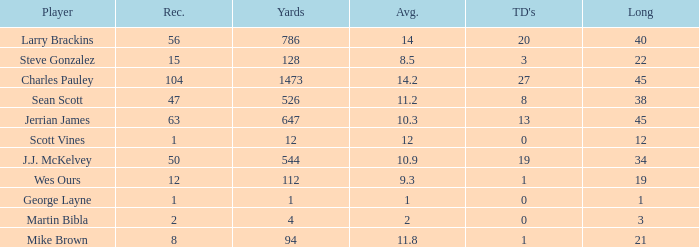What is the average for wes ours with over 1 reception and under 1 TD? None. 